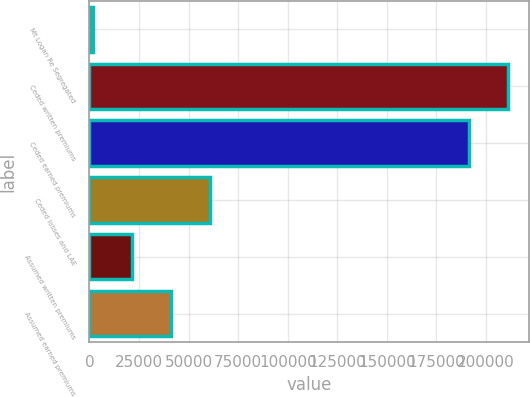Convert chart. <chart><loc_0><loc_0><loc_500><loc_500><bar_chart><fcel>Mt Logan Re Segregated<fcel>Ceded written premiums<fcel>Ceded earned premiums<fcel>Ceded losses and LAE<fcel>Assumed written premiums<fcel>Assumed earned premiums<nl><fcel>2016<fcel>211120<fcel>191568<fcel>60672.3<fcel>21568.1<fcel>41120.2<nl></chart> 